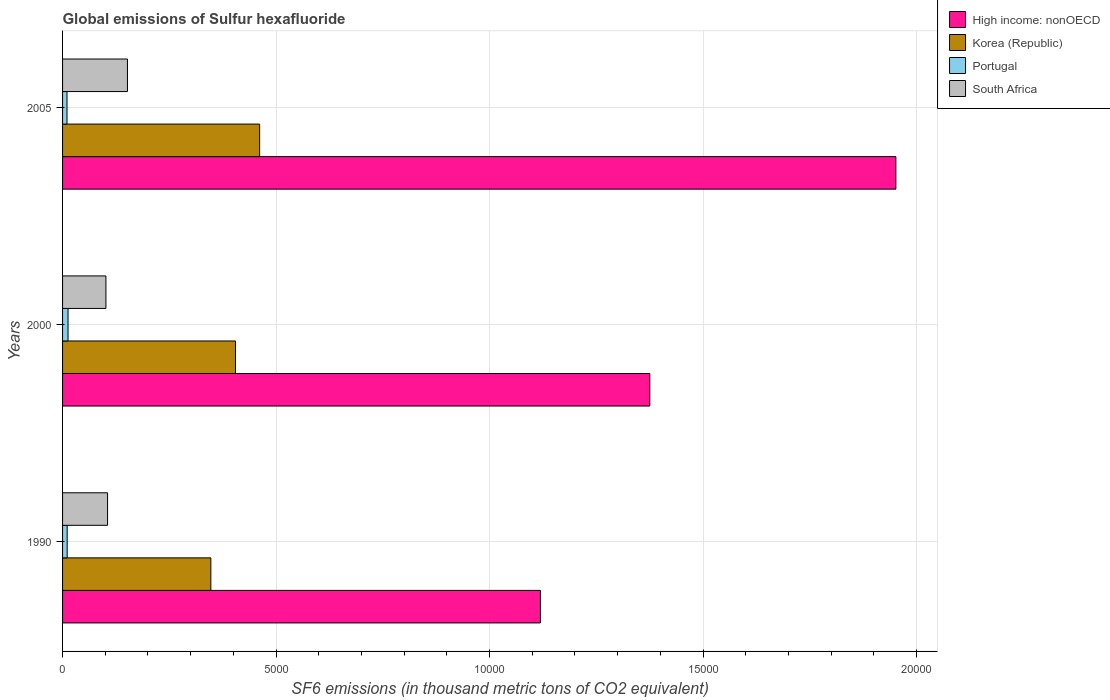How many different coloured bars are there?
Your answer should be compact. 4. How many groups of bars are there?
Offer a very short reply. 3. Are the number of bars per tick equal to the number of legend labels?
Provide a short and direct response. Yes. How many bars are there on the 2nd tick from the top?
Keep it short and to the point. 4. How many bars are there on the 1st tick from the bottom?
Your response must be concise. 4. What is the global emissions of Sulfur hexafluoride in South Africa in 2000?
Your answer should be very brief. 1015.4. Across all years, what is the maximum global emissions of Sulfur hexafluoride in High income: nonOECD?
Provide a succinct answer. 1.95e+04. Across all years, what is the minimum global emissions of Sulfur hexafluoride in High income: nonOECD?
Your response must be concise. 1.12e+04. In which year was the global emissions of Sulfur hexafluoride in South Africa maximum?
Give a very brief answer. 2005. In which year was the global emissions of Sulfur hexafluoride in Korea (Republic) minimum?
Offer a very short reply. 1990. What is the total global emissions of Sulfur hexafluoride in High income: nonOECD in the graph?
Provide a short and direct response. 4.45e+04. What is the difference between the global emissions of Sulfur hexafluoride in High income: nonOECD in 2000 and that in 2005?
Give a very brief answer. -5763.14. What is the difference between the global emissions of Sulfur hexafluoride in South Africa in 1990 and the global emissions of Sulfur hexafluoride in Portugal in 2000?
Your answer should be very brief. 925.9. What is the average global emissions of Sulfur hexafluoride in Korea (Republic) per year?
Make the answer very short. 4046.37. In the year 2000, what is the difference between the global emissions of Sulfur hexafluoride in Portugal and global emissions of Sulfur hexafluoride in Korea (Republic)?
Provide a short and direct response. -3922.5. What is the ratio of the global emissions of Sulfur hexafluoride in Korea (Republic) in 1990 to that in 2000?
Make the answer very short. 0.86. Is the global emissions of Sulfur hexafluoride in Portugal in 1990 less than that in 2005?
Your answer should be compact. No. Is the difference between the global emissions of Sulfur hexafluoride in Portugal in 2000 and 2005 greater than the difference between the global emissions of Sulfur hexafluoride in Korea (Republic) in 2000 and 2005?
Offer a very short reply. Yes. What is the difference between the highest and the second highest global emissions of Sulfur hexafluoride in High income: nonOECD?
Offer a very short reply. 5763.14. What is the difference between the highest and the lowest global emissions of Sulfur hexafluoride in Portugal?
Keep it short and to the point. 24.2. In how many years, is the global emissions of Sulfur hexafluoride in Korea (Republic) greater than the average global emissions of Sulfur hexafluoride in Korea (Republic) taken over all years?
Give a very brief answer. 2. Is the sum of the global emissions of Sulfur hexafluoride in High income: nonOECD in 1990 and 2000 greater than the maximum global emissions of Sulfur hexafluoride in Korea (Republic) across all years?
Your response must be concise. Yes. What does the 3rd bar from the top in 2000 represents?
Give a very brief answer. Korea (Republic). Is it the case that in every year, the sum of the global emissions of Sulfur hexafluoride in Portugal and global emissions of Sulfur hexafluoride in South Africa is greater than the global emissions of Sulfur hexafluoride in High income: nonOECD?
Provide a short and direct response. No. Are all the bars in the graph horizontal?
Provide a short and direct response. Yes. How many years are there in the graph?
Offer a very short reply. 3. Are the values on the major ticks of X-axis written in scientific E-notation?
Provide a short and direct response. No. Does the graph contain any zero values?
Provide a short and direct response. No. Does the graph contain grids?
Your answer should be compact. Yes. Where does the legend appear in the graph?
Your answer should be compact. Top right. How many legend labels are there?
Your answer should be very brief. 4. What is the title of the graph?
Your answer should be compact. Global emissions of Sulfur hexafluoride. Does "Gambia, The" appear as one of the legend labels in the graph?
Ensure brevity in your answer.  No. What is the label or title of the X-axis?
Your answer should be compact. SF6 emissions (in thousand metric tons of CO2 equivalent). What is the SF6 emissions (in thousand metric tons of CO2 equivalent) of High income: nonOECD in 1990?
Keep it short and to the point. 1.12e+04. What is the SF6 emissions (in thousand metric tons of CO2 equivalent) of Korea (Republic) in 1990?
Provide a short and direct response. 3472.9. What is the SF6 emissions (in thousand metric tons of CO2 equivalent) of Portugal in 1990?
Provide a succinct answer. 108. What is the SF6 emissions (in thousand metric tons of CO2 equivalent) of South Africa in 1990?
Give a very brief answer. 1053.9. What is the SF6 emissions (in thousand metric tons of CO2 equivalent) of High income: nonOECD in 2000?
Give a very brief answer. 1.38e+04. What is the SF6 emissions (in thousand metric tons of CO2 equivalent) of Korea (Republic) in 2000?
Make the answer very short. 4050.5. What is the SF6 emissions (in thousand metric tons of CO2 equivalent) of Portugal in 2000?
Your answer should be very brief. 128. What is the SF6 emissions (in thousand metric tons of CO2 equivalent) of South Africa in 2000?
Offer a terse response. 1015.4. What is the SF6 emissions (in thousand metric tons of CO2 equivalent) of High income: nonOECD in 2005?
Offer a very short reply. 1.95e+04. What is the SF6 emissions (in thousand metric tons of CO2 equivalent) of Korea (Republic) in 2005?
Offer a terse response. 4615.7. What is the SF6 emissions (in thousand metric tons of CO2 equivalent) in Portugal in 2005?
Make the answer very short. 103.8. What is the SF6 emissions (in thousand metric tons of CO2 equivalent) in South Africa in 2005?
Your answer should be compact. 1519.7. Across all years, what is the maximum SF6 emissions (in thousand metric tons of CO2 equivalent) in High income: nonOECD?
Keep it short and to the point. 1.95e+04. Across all years, what is the maximum SF6 emissions (in thousand metric tons of CO2 equivalent) of Korea (Republic)?
Offer a terse response. 4615.7. Across all years, what is the maximum SF6 emissions (in thousand metric tons of CO2 equivalent) in Portugal?
Keep it short and to the point. 128. Across all years, what is the maximum SF6 emissions (in thousand metric tons of CO2 equivalent) in South Africa?
Provide a short and direct response. 1519.7. Across all years, what is the minimum SF6 emissions (in thousand metric tons of CO2 equivalent) of High income: nonOECD?
Keep it short and to the point. 1.12e+04. Across all years, what is the minimum SF6 emissions (in thousand metric tons of CO2 equivalent) of Korea (Republic)?
Give a very brief answer. 3472.9. Across all years, what is the minimum SF6 emissions (in thousand metric tons of CO2 equivalent) in Portugal?
Your response must be concise. 103.8. Across all years, what is the minimum SF6 emissions (in thousand metric tons of CO2 equivalent) of South Africa?
Your answer should be compact. 1015.4. What is the total SF6 emissions (in thousand metric tons of CO2 equivalent) in High income: nonOECD in the graph?
Ensure brevity in your answer.  4.45e+04. What is the total SF6 emissions (in thousand metric tons of CO2 equivalent) of Korea (Republic) in the graph?
Your answer should be compact. 1.21e+04. What is the total SF6 emissions (in thousand metric tons of CO2 equivalent) of Portugal in the graph?
Your response must be concise. 339.8. What is the total SF6 emissions (in thousand metric tons of CO2 equivalent) of South Africa in the graph?
Keep it short and to the point. 3589. What is the difference between the SF6 emissions (in thousand metric tons of CO2 equivalent) of High income: nonOECD in 1990 and that in 2000?
Make the answer very short. -2562.3. What is the difference between the SF6 emissions (in thousand metric tons of CO2 equivalent) of Korea (Republic) in 1990 and that in 2000?
Provide a short and direct response. -577.6. What is the difference between the SF6 emissions (in thousand metric tons of CO2 equivalent) of Portugal in 1990 and that in 2000?
Offer a terse response. -20. What is the difference between the SF6 emissions (in thousand metric tons of CO2 equivalent) in South Africa in 1990 and that in 2000?
Offer a very short reply. 38.5. What is the difference between the SF6 emissions (in thousand metric tons of CO2 equivalent) of High income: nonOECD in 1990 and that in 2005?
Offer a terse response. -8325.44. What is the difference between the SF6 emissions (in thousand metric tons of CO2 equivalent) in Korea (Republic) in 1990 and that in 2005?
Provide a succinct answer. -1142.8. What is the difference between the SF6 emissions (in thousand metric tons of CO2 equivalent) of South Africa in 1990 and that in 2005?
Your answer should be compact. -465.8. What is the difference between the SF6 emissions (in thousand metric tons of CO2 equivalent) of High income: nonOECD in 2000 and that in 2005?
Ensure brevity in your answer.  -5763.14. What is the difference between the SF6 emissions (in thousand metric tons of CO2 equivalent) in Korea (Republic) in 2000 and that in 2005?
Provide a short and direct response. -565.2. What is the difference between the SF6 emissions (in thousand metric tons of CO2 equivalent) of Portugal in 2000 and that in 2005?
Offer a very short reply. 24.2. What is the difference between the SF6 emissions (in thousand metric tons of CO2 equivalent) of South Africa in 2000 and that in 2005?
Make the answer very short. -504.3. What is the difference between the SF6 emissions (in thousand metric tons of CO2 equivalent) in High income: nonOECD in 1990 and the SF6 emissions (in thousand metric tons of CO2 equivalent) in Korea (Republic) in 2000?
Your answer should be compact. 7141.7. What is the difference between the SF6 emissions (in thousand metric tons of CO2 equivalent) of High income: nonOECD in 1990 and the SF6 emissions (in thousand metric tons of CO2 equivalent) of Portugal in 2000?
Offer a terse response. 1.11e+04. What is the difference between the SF6 emissions (in thousand metric tons of CO2 equivalent) in High income: nonOECD in 1990 and the SF6 emissions (in thousand metric tons of CO2 equivalent) in South Africa in 2000?
Your response must be concise. 1.02e+04. What is the difference between the SF6 emissions (in thousand metric tons of CO2 equivalent) of Korea (Republic) in 1990 and the SF6 emissions (in thousand metric tons of CO2 equivalent) of Portugal in 2000?
Give a very brief answer. 3344.9. What is the difference between the SF6 emissions (in thousand metric tons of CO2 equivalent) in Korea (Republic) in 1990 and the SF6 emissions (in thousand metric tons of CO2 equivalent) in South Africa in 2000?
Keep it short and to the point. 2457.5. What is the difference between the SF6 emissions (in thousand metric tons of CO2 equivalent) in Portugal in 1990 and the SF6 emissions (in thousand metric tons of CO2 equivalent) in South Africa in 2000?
Your answer should be very brief. -907.4. What is the difference between the SF6 emissions (in thousand metric tons of CO2 equivalent) of High income: nonOECD in 1990 and the SF6 emissions (in thousand metric tons of CO2 equivalent) of Korea (Republic) in 2005?
Offer a very short reply. 6576.5. What is the difference between the SF6 emissions (in thousand metric tons of CO2 equivalent) in High income: nonOECD in 1990 and the SF6 emissions (in thousand metric tons of CO2 equivalent) in Portugal in 2005?
Make the answer very short. 1.11e+04. What is the difference between the SF6 emissions (in thousand metric tons of CO2 equivalent) of High income: nonOECD in 1990 and the SF6 emissions (in thousand metric tons of CO2 equivalent) of South Africa in 2005?
Ensure brevity in your answer.  9672.5. What is the difference between the SF6 emissions (in thousand metric tons of CO2 equivalent) in Korea (Republic) in 1990 and the SF6 emissions (in thousand metric tons of CO2 equivalent) in Portugal in 2005?
Your response must be concise. 3369.1. What is the difference between the SF6 emissions (in thousand metric tons of CO2 equivalent) in Korea (Republic) in 1990 and the SF6 emissions (in thousand metric tons of CO2 equivalent) in South Africa in 2005?
Offer a very short reply. 1953.2. What is the difference between the SF6 emissions (in thousand metric tons of CO2 equivalent) of Portugal in 1990 and the SF6 emissions (in thousand metric tons of CO2 equivalent) of South Africa in 2005?
Your answer should be compact. -1411.7. What is the difference between the SF6 emissions (in thousand metric tons of CO2 equivalent) in High income: nonOECD in 2000 and the SF6 emissions (in thousand metric tons of CO2 equivalent) in Korea (Republic) in 2005?
Offer a terse response. 9138.8. What is the difference between the SF6 emissions (in thousand metric tons of CO2 equivalent) of High income: nonOECD in 2000 and the SF6 emissions (in thousand metric tons of CO2 equivalent) of Portugal in 2005?
Give a very brief answer. 1.37e+04. What is the difference between the SF6 emissions (in thousand metric tons of CO2 equivalent) in High income: nonOECD in 2000 and the SF6 emissions (in thousand metric tons of CO2 equivalent) in South Africa in 2005?
Your answer should be compact. 1.22e+04. What is the difference between the SF6 emissions (in thousand metric tons of CO2 equivalent) in Korea (Republic) in 2000 and the SF6 emissions (in thousand metric tons of CO2 equivalent) in Portugal in 2005?
Offer a very short reply. 3946.7. What is the difference between the SF6 emissions (in thousand metric tons of CO2 equivalent) of Korea (Republic) in 2000 and the SF6 emissions (in thousand metric tons of CO2 equivalent) of South Africa in 2005?
Your answer should be very brief. 2530.8. What is the difference between the SF6 emissions (in thousand metric tons of CO2 equivalent) in Portugal in 2000 and the SF6 emissions (in thousand metric tons of CO2 equivalent) in South Africa in 2005?
Provide a short and direct response. -1391.7. What is the average SF6 emissions (in thousand metric tons of CO2 equivalent) in High income: nonOECD per year?
Your answer should be very brief. 1.48e+04. What is the average SF6 emissions (in thousand metric tons of CO2 equivalent) of Korea (Republic) per year?
Ensure brevity in your answer.  4046.37. What is the average SF6 emissions (in thousand metric tons of CO2 equivalent) in Portugal per year?
Ensure brevity in your answer.  113.27. What is the average SF6 emissions (in thousand metric tons of CO2 equivalent) of South Africa per year?
Give a very brief answer. 1196.33. In the year 1990, what is the difference between the SF6 emissions (in thousand metric tons of CO2 equivalent) of High income: nonOECD and SF6 emissions (in thousand metric tons of CO2 equivalent) of Korea (Republic)?
Your answer should be compact. 7719.3. In the year 1990, what is the difference between the SF6 emissions (in thousand metric tons of CO2 equivalent) of High income: nonOECD and SF6 emissions (in thousand metric tons of CO2 equivalent) of Portugal?
Keep it short and to the point. 1.11e+04. In the year 1990, what is the difference between the SF6 emissions (in thousand metric tons of CO2 equivalent) in High income: nonOECD and SF6 emissions (in thousand metric tons of CO2 equivalent) in South Africa?
Provide a short and direct response. 1.01e+04. In the year 1990, what is the difference between the SF6 emissions (in thousand metric tons of CO2 equivalent) of Korea (Republic) and SF6 emissions (in thousand metric tons of CO2 equivalent) of Portugal?
Provide a succinct answer. 3364.9. In the year 1990, what is the difference between the SF6 emissions (in thousand metric tons of CO2 equivalent) in Korea (Republic) and SF6 emissions (in thousand metric tons of CO2 equivalent) in South Africa?
Offer a terse response. 2419. In the year 1990, what is the difference between the SF6 emissions (in thousand metric tons of CO2 equivalent) in Portugal and SF6 emissions (in thousand metric tons of CO2 equivalent) in South Africa?
Keep it short and to the point. -945.9. In the year 2000, what is the difference between the SF6 emissions (in thousand metric tons of CO2 equivalent) in High income: nonOECD and SF6 emissions (in thousand metric tons of CO2 equivalent) in Korea (Republic)?
Your answer should be very brief. 9704. In the year 2000, what is the difference between the SF6 emissions (in thousand metric tons of CO2 equivalent) in High income: nonOECD and SF6 emissions (in thousand metric tons of CO2 equivalent) in Portugal?
Keep it short and to the point. 1.36e+04. In the year 2000, what is the difference between the SF6 emissions (in thousand metric tons of CO2 equivalent) of High income: nonOECD and SF6 emissions (in thousand metric tons of CO2 equivalent) of South Africa?
Your answer should be very brief. 1.27e+04. In the year 2000, what is the difference between the SF6 emissions (in thousand metric tons of CO2 equivalent) in Korea (Republic) and SF6 emissions (in thousand metric tons of CO2 equivalent) in Portugal?
Provide a succinct answer. 3922.5. In the year 2000, what is the difference between the SF6 emissions (in thousand metric tons of CO2 equivalent) in Korea (Republic) and SF6 emissions (in thousand metric tons of CO2 equivalent) in South Africa?
Ensure brevity in your answer.  3035.1. In the year 2000, what is the difference between the SF6 emissions (in thousand metric tons of CO2 equivalent) in Portugal and SF6 emissions (in thousand metric tons of CO2 equivalent) in South Africa?
Provide a short and direct response. -887.4. In the year 2005, what is the difference between the SF6 emissions (in thousand metric tons of CO2 equivalent) of High income: nonOECD and SF6 emissions (in thousand metric tons of CO2 equivalent) of Korea (Republic)?
Give a very brief answer. 1.49e+04. In the year 2005, what is the difference between the SF6 emissions (in thousand metric tons of CO2 equivalent) of High income: nonOECD and SF6 emissions (in thousand metric tons of CO2 equivalent) of Portugal?
Offer a terse response. 1.94e+04. In the year 2005, what is the difference between the SF6 emissions (in thousand metric tons of CO2 equivalent) in High income: nonOECD and SF6 emissions (in thousand metric tons of CO2 equivalent) in South Africa?
Keep it short and to the point. 1.80e+04. In the year 2005, what is the difference between the SF6 emissions (in thousand metric tons of CO2 equivalent) in Korea (Republic) and SF6 emissions (in thousand metric tons of CO2 equivalent) in Portugal?
Your response must be concise. 4511.9. In the year 2005, what is the difference between the SF6 emissions (in thousand metric tons of CO2 equivalent) in Korea (Republic) and SF6 emissions (in thousand metric tons of CO2 equivalent) in South Africa?
Provide a short and direct response. 3096. In the year 2005, what is the difference between the SF6 emissions (in thousand metric tons of CO2 equivalent) of Portugal and SF6 emissions (in thousand metric tons of CO2 equivalent) of South Africa?
Your answer should be very brief. -1415.9. What is the ratio of the SF6 emissions (in thousand metric tons of CO2 equivalent) in High income: nonOECD in 1990 to that in 2000?
Provide a short and direct response. 0.81. What is the ratio of the SF6 emissions (in thousand metric tons of CO2 equivalent) in Korea (Republic) in 1990 to that in 2000?
Give a very brief answer. 0.86. What is the ratio of the SF6 emissions (in thousand metric tons of CO2 equivalent) of Portugal in 1990 to that in 2000?
Provide a succinct answer. 0.84. What is the ratio of the SF6 emissions (in thousand metric tons of CO2 equivalent) in South Africa in 1990 to that in 2000?
Provide a succinct answer. 1.04. What is the ratio of the SF6 emissions (in thousand metric tons of CO2 equivalent) of High income: nonOECD in 1990 to that in 2005?
Keep it short and to the point. 0.57. What is the ratio of the SF6 emissions (in thousand metric tons of CO2 equivalent) in Korea (Republic) in 1990 to that in 2005?
Offer a very short reply. 0.75. What is the ratio of the SF6 emissions (in thousand metric tons of CO2 equivalent) in Portugal in 1990 to that in 2005?
Provide a short and direct response. 1.04. What is the ratio of the SF6 emissions (in thousand metric tons of CO2 equivalent) of South Africa in 1990 to that in 2005?
Provide a short and direct response. 0.69. What is the ratio of the SF6 emissions (in thousand metric tons of CO2 equivalent) in High income: nonOECD in 2000 to that in 2005?
Offer a very short reply. 0.7. What is the ratio of the SF6 emissions (in thousand metric tons of CO2 equivalent) in Korea (Republic) in 2000 to that in 2005?
Your answer should be very brief. 0.88. What is the ratio of the SF6 emissions (in thousand metric tons of CO2 equivalent) in Portugal in 2000 to that in 2005?
Provide a short and direct response. 1.23. What is the ratio of the SF6 emissions (in thousand metric tons of CO2 equivalent) in South Africa in 2000 to that in 2005?
Your answer should be very brief. 0.67. What is the difference between the highest and the second highest SF6 emissions (in thousand metric tons of CO2 equivalent) of High income: nonOECD?
Ensure brevity in your answer.  5763.14. What is the difference between the highest and the second highest SF6 emissions (in thousand metric tons of CO2 equivalent) in Korea (Republic)?
Your answer should be very brief. 565.2. What is the difference between the highest and the second highest SF6 emissions (in thousand metric tons of CO2 equivalent) of Portugal?
Ensure brevity in your answer.  20. What is the difference between the highest and the second highest SF6 emissions (in thousand metric tons of CO2 equivalent) in South Africa?
Offer a terse response. 465.8. What is the difference between the highest and the lowest SF6 emissions (in thousand metric tons of CO2 equivalent) in High income: nonOECD?
Your answer should be compact. 8325.44. What is the difference between the highest and the lowest SF6 emissions (in thousand metric tons of CO2 equivalent) in Korea (Republic)?
Provide a short and direct response. 1142.8. What is the difference between the highest and the lowest SF6 emissions (in thousand metric tons of CO2 equivalent) in Portugal?
Ensure brevity in your answer.  24.2. What is the difference between the highest and the lowest SF6 emissions (in thousand metric tons of CO2 equivalent) in South Africa?
Keep it short and to the point. 504.3. 